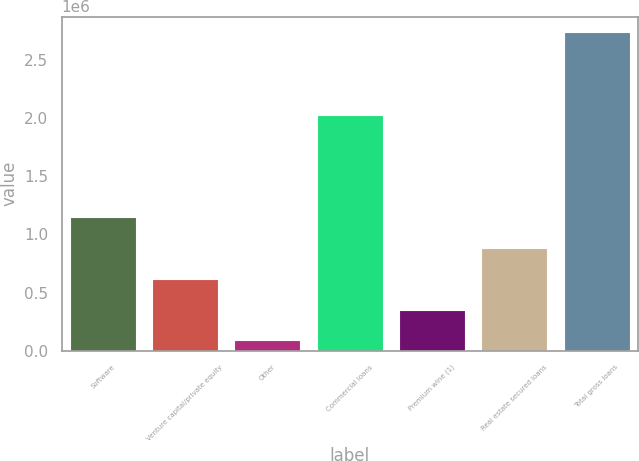Convert chart. <chart><loc_0><loc_0><loc_500><loc_500><bar_chart><fcel>Software<fcel>Venture capital/private equity<fcel>Other<fcel>Commercial loans<fcel>Premium wine (1)<fcel>Real estate secured loans<fcel>Total gross loans<nl><fcel>1.14902e+06<fcel>619363<fcel>89703<fcel>2.02657e+06<fcel>354533<fcel>884193<fcel>2.738e+06<nl></chart> 